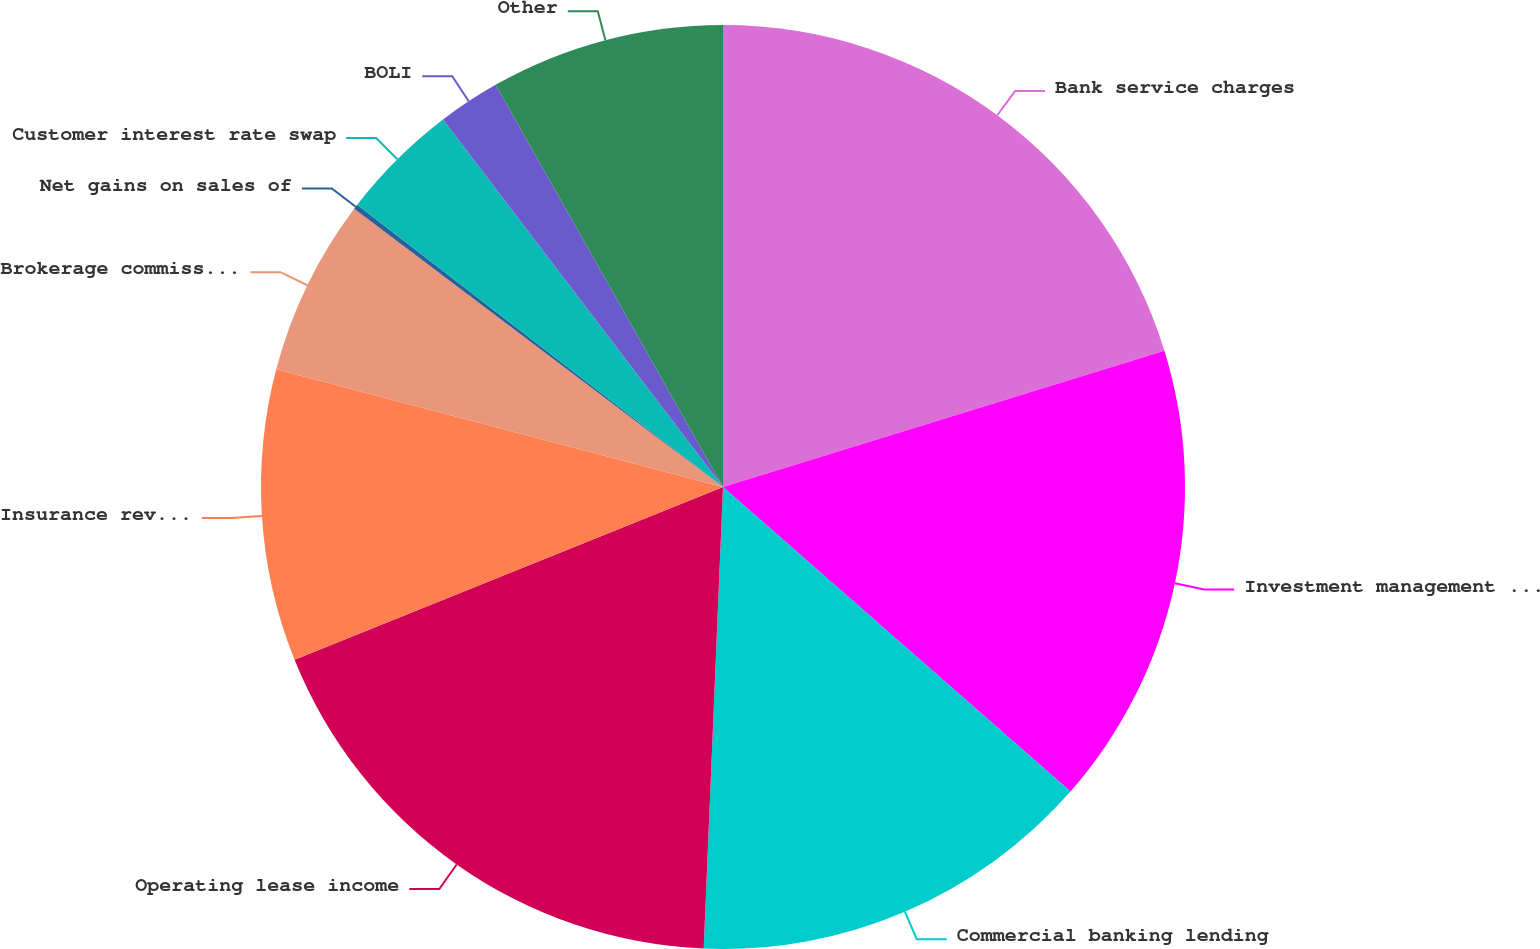Convert chart. <chart><loc_0><loc_0><loc_500><loc_500><pie_chart><fcel>Bank service charges<fcel>Investment management fees<fcel>Commercial banking lending<fcel>Operating lease income<fcel>Insurance revenue<fcel>Brokerage commissions<fcel>Net gains on sales of<fcel>Customer interest rate swap<fcel>BOLI<fcel>Other<nl><fcel>20.23%<fcel>16.22%<fcel>14.21%<fcel>18.23%<fcel>10.2%<fcel>6.19%<fcel>0.17%<fcel>4.18%<fcel>2.17%<fcel>8.19%<nl></chart> 